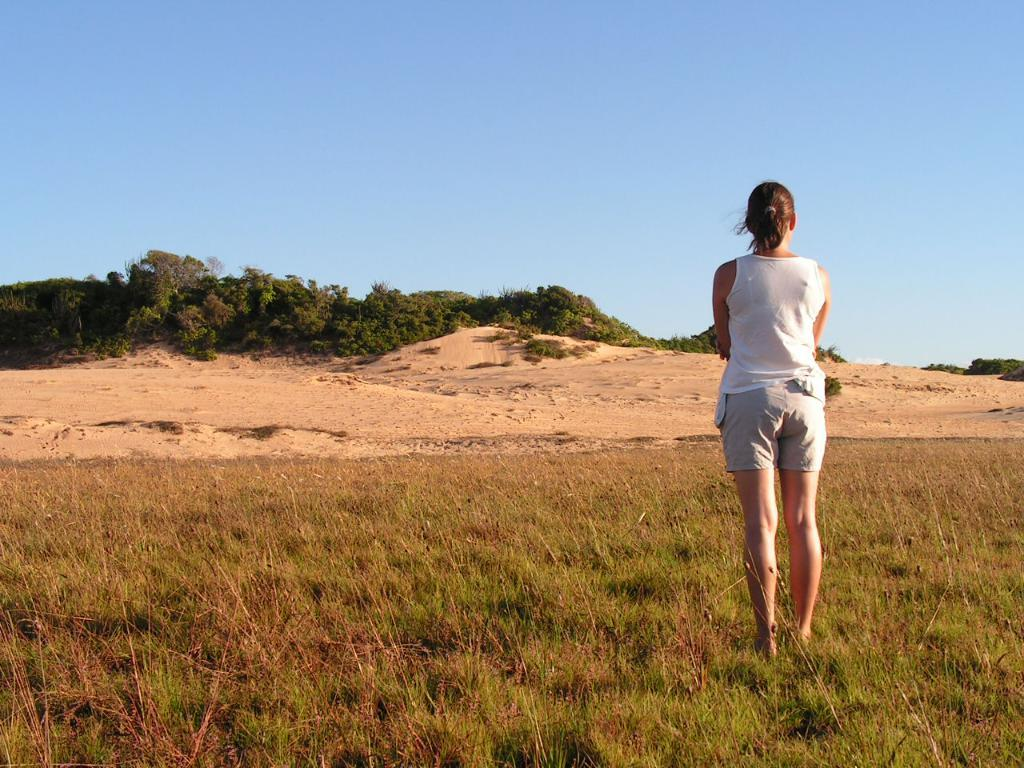What is the main subject of the image? There is a woman standing in the image. What is the woman standing on? The woman is standing on grass. What can be seen in the background of the image? There are plants and sand visible in the background of the image. What is the condition of the sky in the image? The sky is clear and visible at the top of the image. How many heart-shaped balloons can be seen in the image? There are no heart-shaped balloons present in the image. Can you tell me the color of the ladybug on the woman's shoulder? There is no ladybug present on the woman's shoulder in the image. 